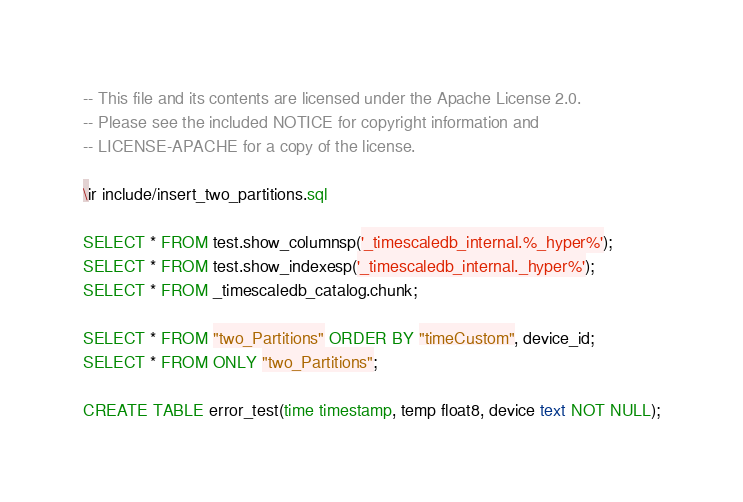Convert code to text. <code><loc_0><loc_0><loc_500><loc_500><_SQL_>-- This file and its contents are licensed under the Apache License 2.0.
-- Please see the included NOTICE for copyright information and
-- LICENSE-APACHE for a copy of the license.

\ir include/insert_two_partitions.sql

SELECT * FROM test.show_columnsp('_timescaledb_internal.%_hyper%');
SELECT * FROM test.show_indexesp('_timescaledb_internal._hyper%');
SELECT * FROM _timescaledb_catalog.chunk;

SELECT * FROM "two_Partitions" ORDER BY "timeCustom", device_id;
SELECT * FROM ONLY "two_Partitions";

CREATE TABLE error_test(time timestamp, temp float8, device text NOT NULL);</code> 